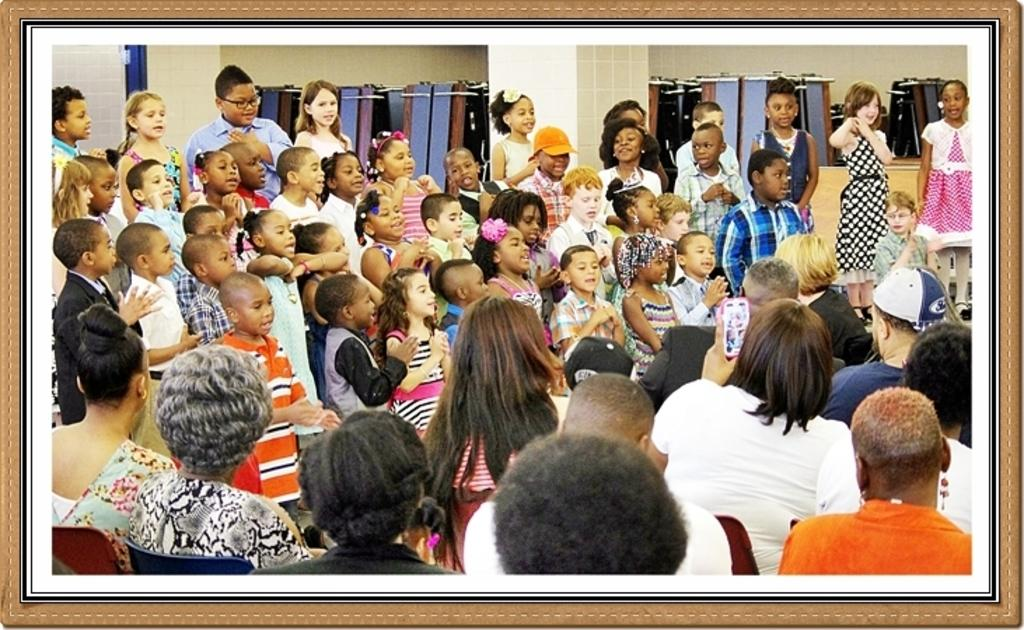What is happening in the image? There is a group of people sitting in the image. Where are the people located in the image? The group of people is at the bottom of the image. Can you describe another group of individuals in the image? There is a group of children in the image. Where are the children located in the image? The group of children is in the middle of the image. What type of train is the servant operating in the image? There is no train or servant present in the image. 